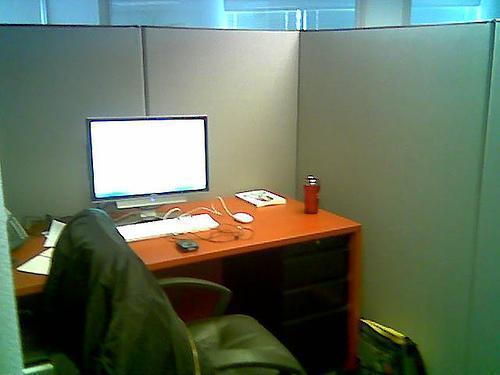How many chairs are in the picture?
Give a very brief answer. 1. How many cows are here?
Give a very brief answer. 0. 